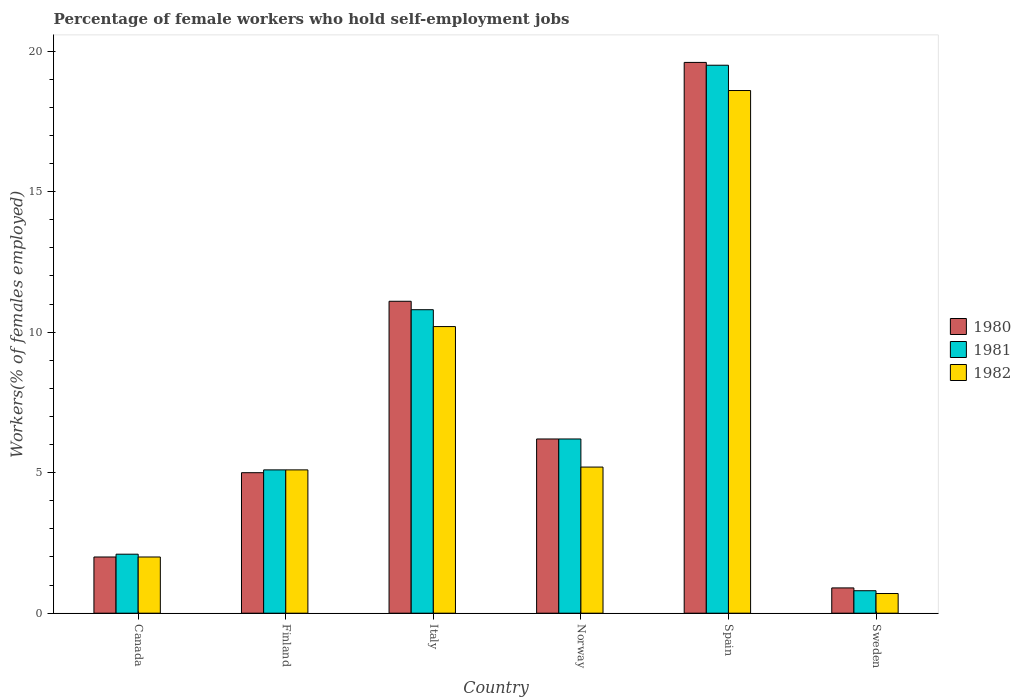How many different coloured bars are there?
Give a very brief answer. 3. How many groups of bars are there?
Offer a terse response. 6. In how many cases, is the number of bars for a given country not equal to the number of legend labels?
Your answer should be very brief. 0. What is the percentage of self-employed female workers in 1980 in Sweden?
Provide a succinct answer. 0.9. Across all countries, what is the maximum percentage of self-employed female workers in 1980?
Your answer should be very brief. 19.6. Across all countries, what is the minimum percentage of self-employed female workers in 1980?
Keep it short and to the point. 0.9. In which country was the percentage of self-employed female workers in 1980 maximum?
Your answer should be compact. Spain. What is the total percentage of self-employed female workers in 1980 in the graph?
Provide a short and direct response. 44.8. What is the difference between the percentage of self-employed female workers in 1981 in Norway and that in Spain?
Your response must be concise. -13.3. What is the difference between the percentage of self-employed female workers in 1980 in Spain and the percentage of self-employed female workers in 1982 in Sweden?
Make the answer very short. 18.9. What is the average percentage of self-employed female workers in 1980 per country?
Ensure brevity in your answer.  7.47. What is the difference between the percentage of self-employed female workers of/in 1980 and percentage of self-employed female workers of/in 1981 in Finland?
Your answer should be very brief. -0.1. In how many countries, is the percentage of self-employed female workers in 1980 greater than 8 %?
Give a very brief answer. 2. What is the ratio of the percentage of self-employed female workers in 1981 in Finland to that in Sweden?
Offer a very short reply. 6.37. Is the percentage of self-employed female workers in 1981 in Italy less than that in Sweden?
Make the answer very short. No. What is the difference between the highest and the second highest percentage of self-employed female workers in 1982?
Provide a short and direct response. 8.4. What is the difference between the highest and the lowest percentage of self-employed female workers in 1982?
Your response must be concise. 17.9. Is it the case that in every country, the sum of the percentage of self-employed female workers in 1980 and percentage of self-employed female workers in 1981 is greater than the percentage of self-employed female workers in 1982?
Keep it short and to the point. Yes. Are all the bars in the graph horizontal?
Keep it short and to the point. No. How many countries are there in the graph?
Ensure brevity in your answer.  6. What is the difference between two consecutive major ticks on the Y-axis?
Provide a succinct answer. 5. Does the graph contain any zero values?
Offer a very short reply. No. How are the legend labels stacked?
Make the answer very short. Vertical. What is the title of the graph?
Your answer should be compact. Percentage of female workers who hold self-employment jobs. Does "2000" appear as one of the legend labels in the graph?
Your answer should be compact. No. What is the label or title of the Y-axis?
Keep it short and to the point. Workers(% of females employed). What is the Workers(% of females employed) of 1981 in Canada?
Your response must be concise. 2.1. What is the Workers(% of females employed) in 1982 in Canada?
Provide a short and direct response. 2. What is the Workers(% of females employed) in 1981 in Finland?
Provide a short and direct response. 5.1. What is the Workers(% of females employed) of 1982 in Finland?
Your answer should be very brief. 5.1. What is the Workers(% of females employed) of 1980 in Italy?
Your answer should be compact. 11.1. What is the Workers(% of females employed) of 1981 in Italy?
Offer a terse response. 10.8. What is the Workers(% of females employed) of 1982 in Italy?
Your answer should be compact. 10.2. What is the Workers(% of females employed) in 1980 in Norway?
Offer a very short reply. 6.2. What is the Workers(% of females employed) in 1981 in Norway?
Your answer should be compact. 6.2. What is the Workers(% of females employed) of 1982 in Norway?
Offer a very short reply. 5.2. What is the Workers(% of females employed) in 1980 in Spain?
Offer a terse response. 19.6. What is the Workers(% of females employed) of 1982 in Spain?
Provide a short and direct response. 18.6. What is the Workers(% of females employed) in 1980 in Sweden?
Keep it short and to the point. 0.9. What is the Workers(% of females employed) of 1981 in Sweden?
Give a very brief answer. 0.8. What is the Workers(% of females employed) of 1982 in Sweden?
Provide a short and direct response. 0.7. Across all countries, what is the maximum Workers(% of females employed) of 1980?
Provide a succinct answer. 19.6. Across all countries, what is the maximum Workers(% of females employed) of 1982?
Provide a short and direct response. 18.6. Across all countries, what is the minimum Workers(% of females employed) of 1980?
Make the answer very short. 0.9. Across all countries, what is the minimum Workers(% of females employed) of 1981?
Your answer should be compact. 0.8. Across all countries, what is the minimum Workers(% of females employed) in 1982?
Provide a short and direct response. 0.7. What is the total Workers(% of females employed) of 1980 in the graph?
Provide a short and direct response. 44.8. What is the total Workers(% of females employed) in 1981 in the graph?
Provide a short and direct response. 44.5. What is the total Workers(% of females employed) in 1982 in the graph?
Provide a short and direct response. 41.8. What is the difference between the Workers(% of females employed) of 1980 in Canada and that in Finland?
Provide a short and direct response. -3. What is the difference between the Workers(% of females employed) in 1982 in Canada and that in Finland?
Your answer should be very brief. -3.1. What is the difference between the Workers(% of females employed) of 1980 in Canada and that in Italy?
Ensure brevity in your answer.  -9.1. What is the difference between the Workers(% of females employed) of 1981 in Canada and that in Norway?
Make the answer very short. -4.1. What is the difference between the Workers(% of females employed) in 1982 in Canada and that in Norway?
Your answer should be compact. -3.2. What is the difference between the Workers(% of females employed) of 1980 in Canada and that in Spain?
Your response must be concise. -17.6. What is the difference between the Workers(% of females employed) in 1981 in Canada and that in Spain?
Ensure brevity in your answer.  -17.4. What is the difference between the Workers(% of females employed) in 1982 in Canada and that in Spain?
Provide a succinct answer. -16.6. What is the difference between the Workers(% of females employed) of 1980 in Canada and that in Sweden?
Ensure brevity in your answer.  1.1. What is the difference between the Workers(% of females employed) of 1980 in Finland and that in Italy?
Offer a terse response. -6.1. What is the difference between the Workers(% of females employed) in 1980 in Finland and that in Spain?
Keep it short and to the point. -14.6. What is the difference between the Workers(% of females employed) in 1981 in Finland and that in Spain?
Your answer should be compact. -14.4. What is the difference between the Workers(% of females employed) of 1982 in Finland and that in Spain?
Provide a short and direct response. -13.5. What is the difference between the Workers(% of females employed) of 1980 in Finland and that in Sweden?
Provide a short and direct response. 4.1. What is the difference between the Workers(% of females employed) of 1982 in Finland and that in Sweden?
Provide a short and direct response. 4.4. What is the difference between the Workers(% of females employed) of 1981 in Italy and that in Norway?
Provide a succinct answer. 4.6. What is the difference between the Workers(% of females employed) of 1981 in Italy and that in Sweden?
Give a very brief answer. 10. What is the difference between the Workers(% of females employed) of 1981 in Norway and that in Spain?
Offer a terse response. -13.3. What is the difference between the Workers(% of females employed) in 1981 in Norway and that in Sweden?
Give a very brief answer. 5.4. What is the difference between the Workers(% of females employed) of 1980 in Spain and that in Sweden?
Provide a succinct answer. 18.7. What is the difference between the Workers(% of females employed) in 1982 in Spain and that in Sweden?
Your answer should be compact. 17.9. What is the difference between the Workers(% of females employed) in 1980 in Canada and the Workers(% of females employed) in 1981 in Finland?
Make the answer very short. -3.1. What is the difference between the Workers(% of females employed) in 1980 in Canada and the Workers(% of females employed) in 1982 in Finland?
Offer a very short reply. -3.1. What is the difference between the Workers(% of females employed) in 1981 in Canada and the Workers(% of females employed) in 1982 in Finland?
Provide a succinct answer. -3. What is the difference between the Workers(% of females employed) of 1980 in Canada and the Workers(% of females employed) of 1981 in Italy?
Give a very brief answer. -8.8. What is the difference between the Workers(% of females employed) in 1981 in Canada and the Workers(% of females employed) in 1982 in Italy?
Make the answer very short. -8.1. What is the difference between the Workers(% of females employed) in 1980 in Canada and the Workers(% of females employed) in 1982 in Norway?
Your answer should be compact. -3.2. What is the difference between the Workers(% of females employed) in 1981 in Canada and the Workers(% of females employed) in 1982 in Norway?
Provide a succinct answer. -3.1. What is the difference between the Workers(% of females employed) of 1980 in Canada and the Workers(% of females employed) of 1981 in Spain?
Your response must be concise. -17.5. What is the difference between the Workers(% of females employed) of 1980 in Canada and the Workers(% of females employed) of 1982 in Spain?
Your answer should be very brief. -16.6. What is the difference between the Workers(% of females employed) in 1981 in Canada and the Workers(% of females employed) in 1982 in Spain?
Give a very brief answer. -16.5. What is the difference between the Workers(% of females employed) of 1980 in Canada and the Workers(% of females employed) of 1982 in Sweden?
Your response must be concise. 1.3. What is the difference between the Workers(% of females employed) of 1980 in Finland and the Workers(% of females employed) of 1982 in Italy?
Your answer should be compact. -5.2. What is the difference between the Workers(% of females employed) in 1980 in Finland and the Workers(% of females employed) in 1981 in Spain?
Provide a succinct answer. -14.5. What is the difference between the Workers(% of females employed) in 1980 in Finland and the Workers(% of females employed) in 1982 in Spain?
Your response must be concise. -13.6. What is the difference between the Workers(% of females employed) in 1980 in Finland and the Workers(% of females employed) in 1981 in Sweden?
Offer a terse response. 4.2. What is the difference between the Workers(% of females employed) of 1980 in Italy and the Workers(% of females employed) of 1981 in Norway?
Give a very brief answer. 4.9. What is the difference between the Workers(% of females employed) of 1980 in Italy and the Workers(% of females employed) of 1981 in Spain?
Your answer should be compact. -8.4. What is the difference between the Workers(% of females employed) in 1980 in Italy and the Workers(% of females employed) in 1982 in Sweden?
Provide a short and direct response. 10.4. What is the difference between the Workers(% of females employed) in 1981 in Italy and the Workers(% of females employed) in 1982 in Sweden?
Offer a terse response. 10.1. What is the difference between the Workers(% of females employed) of 1981 in Norway and the Workers(% of females employed) of 1982 in Spain?
Offer a terse response. -12.4. What is the difference between the Workers(% of females employed) in 1980 in Norway and the Workers(% of females employed) in 1981 in Sweden?
Ensure brevity in your answer.  5.4. What is the difference between the Workers(% of females employed) in 1980 in Norway and the Workers(% of females employed) in 1982 in Sweden?
Keep it short and to the point. 5.5. What is the difference between the Workers(% of females employed) in 1981 in Norway and the Workers(% of females employed) in 1982 in Sweden?
Offer a very short reply. 5.5. What is the difference between the Workers(% of females employed) of 1980 in Spain and the Workers(% of females employed) of 1981 in Sweden?
Keep it short and to the point. 18.8. What is the average Workers(% of females employed) of 1980 per country?
Your response must be concise. 7.47. What is the average Workers(% of females employed) in 1981 per country?
Provide a short and direct response. 7.42. What is the average Workers(% of females employed) of 1982 per country?
Make the answer very short. 6.97. What is the difference between the Workers(% of females employed) in 1980 and Workers(% of females employed) in 1981 in Finland?
Your response must be concise. -0.1. What is the difference between the Workers(% of females employed) of 1981 and Workers(% of females employed) of 1982 in Finland?
Provide a succinct answer. 0. What is the difference between the Workers(% of females employed) of 1980 and Workers(% of females employed) of 1981 in Italy?
Keep it short and to the point. 0.3. What is the difference between the Workers(% of females employed) in 1980 and Workers(% of females employed) in 1982 in Italy?
Give a very brief answer. 0.9. What is the difference between the Workers(% of females employed) of 1980 and Workers(% of females employed) of 1982 in Norway?
Your response must be concise. 1. What is the difference between the Workers(% of females employed) of 1981 and Workers(% of females employed) of 1982 in Norway?
Give a very brief answer. 1. What is the ratio of the Workers(% of females employed) of 1980 in Canada to that in Finland?
Offer a very short reply. 0.4. What is the ratio of the Workers(% of females employed) in 1981 in Canada to that in Finland?
Ensure brevity in your answer.  0.41. What is the ratio of the Workers(% of females employed) in 1982 in Canada to that in Finland?
Make the answer very short. 0.39. What is the ratio of the Workers(% of females employed) in 1980 in Canada to that in Italy?
Ensure brevity in your answer.  0.18. What is the ratio of the Workers(% of females employed) in 1981 in Canada to that in Italy?
Your answer should be very brief. 0.19. What is the ratio of the Workers(% of females employed) of 1982 in Canada to that in Italy?
Give a very brief answer. 0.2. What is the ratio of the Workers(% of females employed) of 1980 in Canada to that in Norway?
Give a very brief answer. 0.32. What is the ratio of the Workers(% of females employed) of 1981 in Canada to that in Norway?
Your answer should be compact. 0.34. What is the ratio of the Workers(% of females employed) of 1982 in Canada to that in Norway?
Your response must be concise. 0.38. What is the ratio of the Workers(% of females employed) in 1980 in Canada to that in Spain?
Ensure brevity in your answer.  0.1. What is the ratio of the Workers(% of females employed) in 1981 in Canada to that in Spain?
Ensure brevity in your answer.  0.11. What is the ratio of the Workers(% of females employed) of 1982 in Canada to that in Spain?
Your answer should be very brief. 0.11. What is the ratio of the Workers(% of females employed) in 1980 in Canada to that in Sweden?
Give a very brief answer. 2.22. What is the ratio of the Workers(% of females employed) in 1981 in Canada to that in Sweden?
Your answer should be very brief. 2.62. What is the ratio of the Workers(% of females employed) in 1982 in Canada to that in Sweden?
Provide a succinct answer. 2.86. What is the ratio of the Workers(% of females employed) of 1980 in Finland to that in Italy?
Ensure brevity in your answer.  0.45. What is the ratio of the Workers(% of females employed) in 1981 in Finland to that in Italy?
Offer a very short reply. 0.47. What is the ratio of the Workers(% of females employed) of 1982 in Finland to that in Italy?
Provide a succinct answer. 0.5. What is the ratio of the Workers(% of females employed) in 1980 in Finland to that in Norway?
Offer a very short reply. 0.81. What is the ratio of the Workers(% of females employed) in 1981 in Finland to that in Norway?
Your answer should be very brief. 0.82. What is the ratio of the Workers(% of females employed) of 1982 in Finland to that in Norway?
Provide a succinct answer. 0.98. What is the ratio of the Workers(% of females employed) of 1980 in Finland to that in Spain?
Make the answer very short. 0.26. What is the ratio of the Workers(% of females employed) of 1981 in Finland to that in Spain?
Provide a short and direct response. 0.26. What is the ratio of the Workers(% of females employed) in 1982 in Finland to that in Spain?
Offer a very short reply. 0.27. What is the ratio of the Workers(% of females employed) of 1980 in Finland to that in Sweden?
Provide a succinct answer. 5.56. What is the ratio of the Workers(% of females employed) of 1981 in Finland to that in Sweden?
Provide a short and direct response. 6.38. What is the ratio of the Workers(% of females employed) of 1982 in Finland to that in Sweden?
Provide a short and direct response. 7.29. What is the ratio of the Workers(% of females employed) of 1980 in Italy to that in Norway?
Offer a terse response. 1.79. What is the ratio of the Workers(% of females employed) of 1981 in Italy to that in Norway?
Offer a terse response. 1.74. What is the ratio of the Workers(% of females employed) in 1982 in Italy to that in Norway?
Your answer should be compact. 1.96. What is the ratio of the Workers(% of females employed) in 1980 in Italy to that in Spain?
Keep it short and to the point. 0.57. What is the ratio of the Workers(% of females employed) of 1981 in Italy to that in Spain?
Make the answer very short. 0.55. What is the ratio of the Workers(% of females employed) in 1982 in Italy to that in Spain?
Keep it short and to the point. 0.55. What is the ratio of the Workers(% of females employed) of 1980 in Italy to that in Sweden?
Your response must be concise. 12.33. What is the ratio of the Workers(% of females employed) of 1982 in Italy to that in Sweden?
Offer a terse response. 14.57. What is the ratio of the Workers(% of females employed) of 1980 in Norway to that in Spain?
Ensure brevity in your answer.  0.32. What is the ratio of the Workers(% of females employed) of 1981 in Norway to that in Spain?
Your response must be concise. 0.32. What is the ratio of the Workers(% of females employed) of 1982 in Norway to that in Spain?
Your response must be concise. 0.28. What is the ratio of the Workers(% of females employed) in 1980 in Norway to that in Sweden?
Offer a very short reply. 6.89. What is the ratio of the Workers(% of females employed) of 1981 in Norway to that in Sweden?
Ensure brevity in your answer.  7.75. What is the ratio of the Workers(% of females employed) in 1982 in Norway to that in Sweden?
Make the answer very short. 7.43. What is the ratio of the Workers(% of females employed) in 1980 in Spain to that in Sweden?
Your answer should be compact. 21.78. What is the ratio of the Workers(% of females employed) in 1981 in Spain to that in Sweden?
Offer a very short reply. 24.38. What is the ratio of the Workers(% of females employed) of 1982 in Spain to that in Sweden?
Make the answer very short. 26.57. What is the difference between the highest and the second highest Workers(% of females employed) in 1980?
Provide a short and direct response. 8.5. What is the difference between the highest and the second highest Workers(% of females employed) in 1982?
Your answer should be compact. 8.4. What is the difference between the highest and the lowest Workers(% of females employed) in 1982?
Your response must be concise. 17.9. 